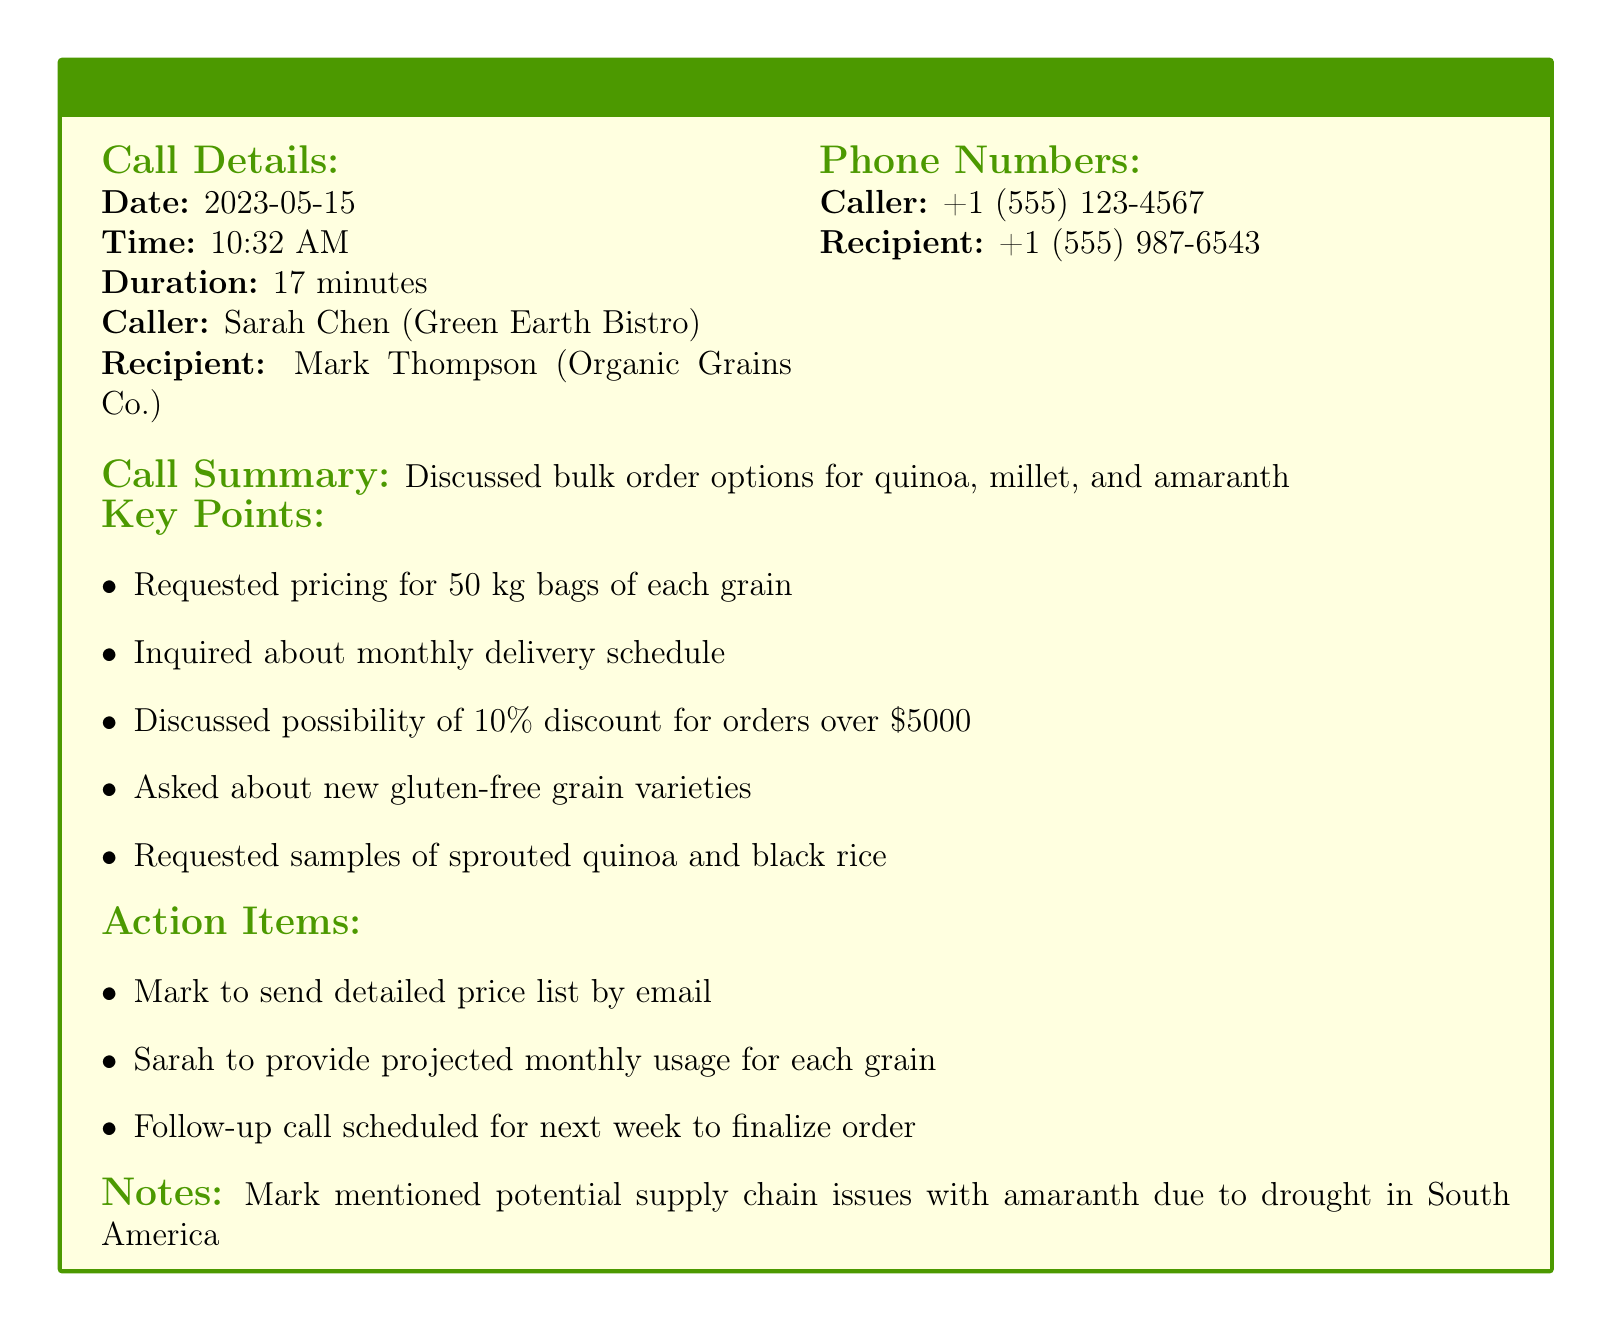What date did the call take place? The date of the call is listed under Call Details as 2023-05-15.
Answer: 2023-05-15 Who was the caller? The caller's name is specified in the Call Details section as Sarah Chen.
Answer: Sarah Chen What was the duration of the call? The duration is provided in the Call Details section as 17 minutes.
Answer: 17 minutes What discount was discussed for orders over $5000? The key points mention a 10% discount for orders exceeding $5000.
Answer: 10% What are the grains discussed for bulk ordering? The call summary states that quinoa, millet, and amaranth were discussed for bulk orders.
Answer: quinoa, millet, and amaranth What action is Mark responsible for? The action items section states that Mark needs to send a detailed price list by email.
Answer: Send detailed price list Why might there be supply chain issues with amaranth? It is mentioned in the Notes section that the supply chain issues are due to drought in South America.
Answer: Drought in South America When is the follow-up call scheduled? The call log does not provide a specific date but mentions it will be next week.
Answer: Next week 